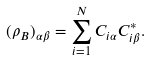Convert formula to latex. <formula><loc_0><loc_0><loc_500><loc_500>( \rho _ { B } ) _ { \alpha \beta } = \sum _ { i = 1 } ^ { N } C _ { i \alpha } C ^ { * } _ { i \beta } .</formula> 